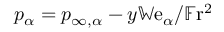<formula> <loc_0><loc_0><loc_500><loc_500>p _ { \alpha } = p _ { \infty , \alpha } - y \mathbb { W } e _ { \alpha } / \mathbb { F } r ^ { 2 }</formula> 